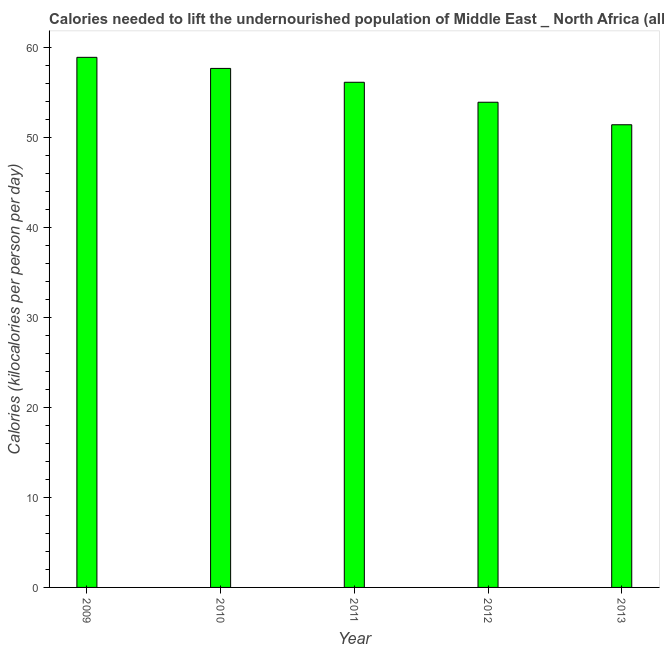What is the title of the graph?
Your response must be concise. Calories needed to lift the undernourished population of Middle East _ North Africa (all income levels). What is the label or title of the Y-axis?
Offer a very short reply. Calories (kilocalories per person per day). What is the depth of food deficit in 2011?
Provide a short and direct response. 56.18. Across all years, what is the maximum depth of food deficit?
Your response must be concise. 58.95. Across all years, what is the minimum depth of food deficit?
Offer a terse response. 51.45. In which year was the depth of food deficit minimum?
Give a very brief answer. 2013. What is the sum of the depth of food deficit?
Make the answer very short. 278.27. What is the difference between the depth of food deficit in 2009 and 2012?
Keep it short and to the point. 5. What is the average depth of food deficit per year?
Ensure brevity in your answer.  55.65. What is the median depth of food deficit?
Your answer should be very brief. 56.18. In how many years, is the depth of food deficit greater than 10 kilocalories?
Ensure brevity in your answer.  5. What is the ratio of the depth of food deficit in 2011 to that in 2013?
Your response must be concise. 1.09. What is the difference between the highest and the second highest depth of food deficit?
Offer a terse response. 1.23. What is the difference between the highest and the lowest depth of food deficit?
Give a very brief answer. 7.5. In how many years, is the depth of food deficit greater than the average depth of food deficit taken over all years?
Your answer should be compact. 3. What is the difference between two consecutive major ticks on the Y-axis?
Your answer should be compact. 10. What is the Calories (kilocalories per person per day) in 2009?
Your response must be concise. 58.95. What is the Calories (kilocalories per person per day) in 2010?
Ensure brevity in your answer.  57.72. What is the Calories (kilocalories per person per day) of 2011?
Give a very brief answer. 56.18. What is the Calories (kilocalories per person per day) in 2012?
Provide a short and direct response. 53.96. What is the Calories (kilocalories per person per day) of 2013?
Ensure brevity in your answer.  51.45. What is the difference between the Calories (kilocalories per person per day) in 2009 and 2010?
Ensure brevity in your answer.  1.23. What is the difference between the Calories (kilocalories per person per day) in 2009 and 2011?
Provide a succinct answer. 2.77. What is the difference between the Calories (kilocalories per person per day) in 2009 and 2012?
Offer a very short reply. 5. What is the difference between the Calories (kilocalories per person per day) in 2009 and 2013?
Provide a succinct answer. 7.5. What is the difference between the Calories (kilocalories per person per day) in 2010 and 2011?
Your answer should be very brief. 1.54. What is the difference between the Calories (kilocalories per person per day) in 2010 and 2012?
Give a very brief answer. 3.76. What is the difference between the Calories (kilocalories per person per day) in 2010 and 2013?
Offer a terse response. 6.27. What is the difference between the Calories (kilocalories per person per day) in 2011 and 2012?
Make the answer very short. 2.22. What is the difference between the Calories (kilocalories per person per day) in 2011 and 2013?
Make the answer very short. 4.73. What is the difference between the Calories (kilocalories per person per day) in 2012 and 2013?
Your answer should be very brief. 2.5. What is the ratio of the Calories (kilocalories per person per day) in 2009 to that in 2010?
Make the answer very short. 1.02. What is the ratio of the Calories (kilocalories per person per day) in 2009 to that in 2011?
Ensure brevity in your answer.  1.05. What is the ratio of the Calories (kilocalories per person per day) in 2009 to that in 2012?
Keep it short and to the point. 1.09. What is the ratio of the Calories (kilocalories per person per day) in 2009 to that in 2013?
Provide a succinct answer. 1.15. What is the ratio of the Calories (kilocalories per person per day) in 2010 to that in 2011?
Offer a terse response. 1.03. What is the ratio of the Calories (kilocalories per person per day) in 2010 to that in 2012?
Make the answer very short. 1.07. What is the ratio of the Calories (kilocalories per person per day) in 2010 to that in 2013?
Provide a short and direct response. 1.12. What is the ratio of the Calories (kilocalories per person per day) in 2011 to that in 2012?
Ensure brevity in your answer.  1.04. What is the ratio of the Calories (kilocalories per person per day) in 2011 to that in 2013?
Your answer should be compact. 1.09. What is the ratio of the Calories (kilocalories per person per day) in 2012 to that in 2013?
Your answer should be very brief. 1.05. 